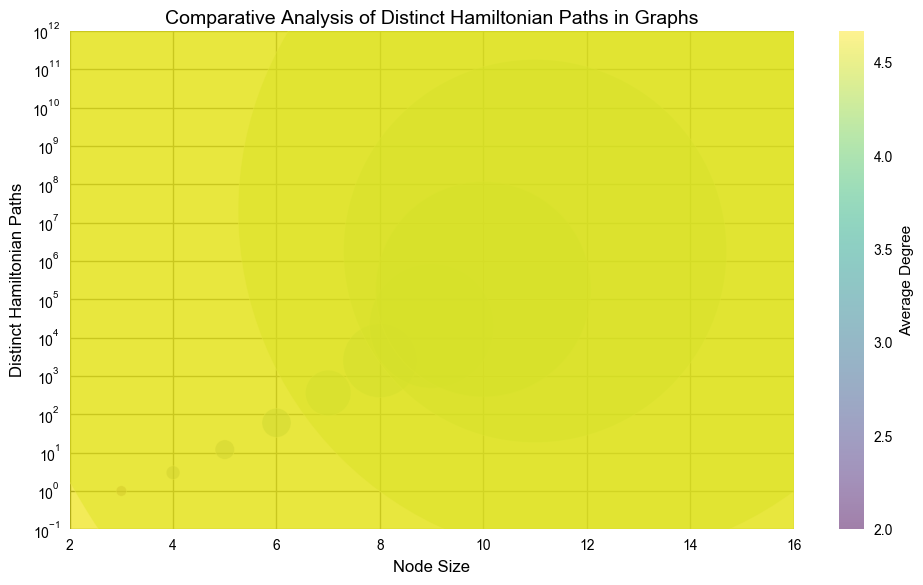What's the node size with the highest number of distinct Hamiltonian paths? The highest number of distinct Hamiltonian paths is represented by the largest bubble in the figure, which corresponds to the node size on the x-axis. The largest bubble is at node size 15.
Answer: 15 Which node size has an average degree of 4.0? The color bar indicates the average degree, and we look for the bubble corresponding to an average degree of 4.0. This bubble aligns with a node size of 11 on the x-axis.
Answer: 11 How does the number of distinct Hamiltonian paths change as the node size increases from 3 to 6? The y-axis uses a logarithmic scale to represent the number of distinct Hamiltonian paths. As the node size increases from 3 to 6, the bubbles grow larger and the y-values increase significantly from 1 to 60.
Answer: Increases significantly Which node size has the smallest bubble? The size of the bubbles corresponds to the number of distinct Hamiltonian paths. The smallest bubble on the chart is at node size 3.
Answer: 3 What is the average degree range for node sizes from 3 to 5? The average degrees are given by the color of the bubbles. For node size 3, the average degree is 2. For node size 4, it’s 2.67, and for node size 5, it's 2.8. Therefore, the range is from 2 to 2.8.
Answer: 2 to 2.8 At which node size does the average degree start to exceed 4? By observing the color transition in the plot, the bubbles start showing average degrees higher than 4 at node size 11. This matches with the color bar scaling on the side.
Answer: 11 What is the total number of distinct Hamiltonian paths for node sizes 3 and 9 combined? Referring to the y-values, node size 3 has 1 path and node size 9 has 20,160 paths. Adding these together, 1 + 20160 = 20161.
Answer: 20161 Which node size has the largest increase in the number of distinct Hamiltonian paths compared to the previous node size? By observing the figure, the increase from node size 14 to 15 has an immense leap. From approximately 3.1 billion at node size 14 to about 43.6 billion at node size 15.
Answer: 15 